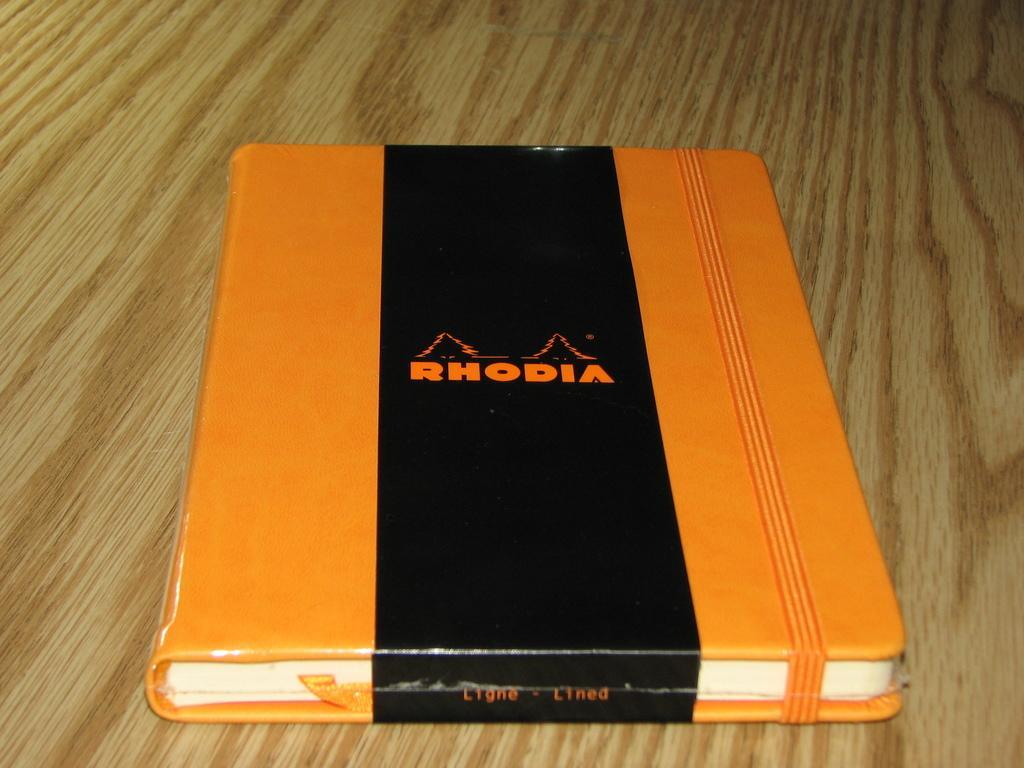<image>
Present a compact description of the photo's key features. an orange book with a black wide band down the middle saying RHODIA in orange letters. 